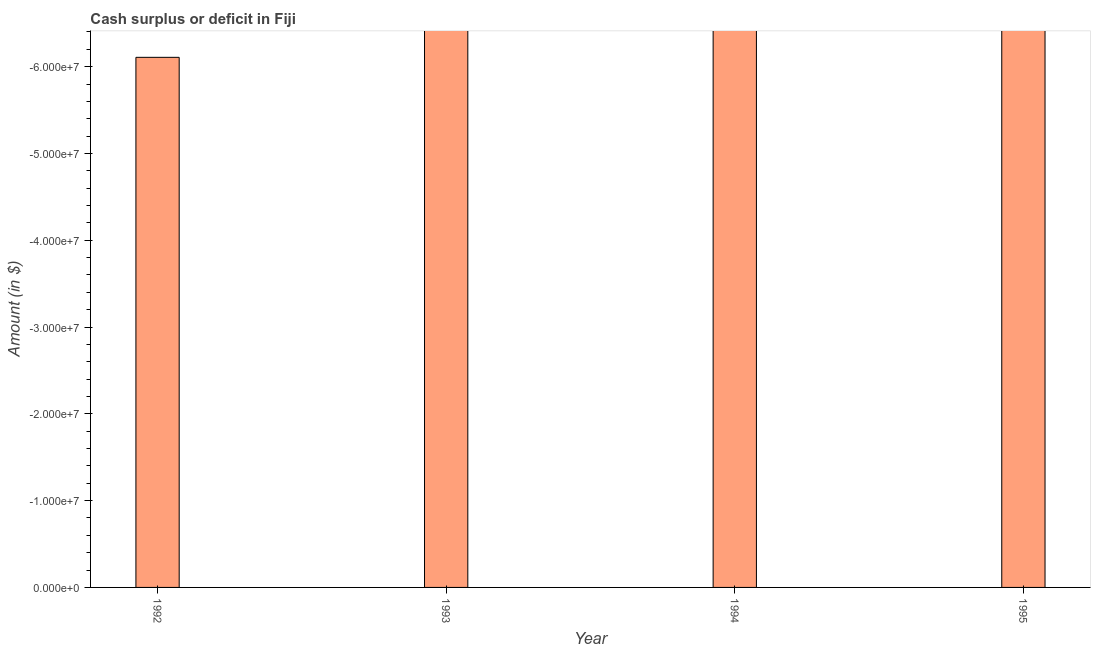Does the graph contain any zero values?
Ensure brevity in your answer.  Yes. Does the graph contain grids?
Offer a terse response. No. What is the title of the graph?
Provide a succinct answer. Cash surplus or deficit in Fiji. What is the label or title of the X-axis?
Offer a terse response. Year. What is the label or title of the Y-axis?
Provide a short and direct response. Amount (in $). What is the median cash surplus or deficit?
Your response must be concise. 0. In how many years, is the cash surplus or deficit greater than -30000000 $?
Your response must be concise. 0. What is the difference between two consecutive major ticks on the Y-axis?
Offer a terse response. 1.00e+07. What is the Amount (in $) of 1994?
Provide a succinct answer. 0. What is the Amount (in $) of 1995?
Your response must be concise. 0. 